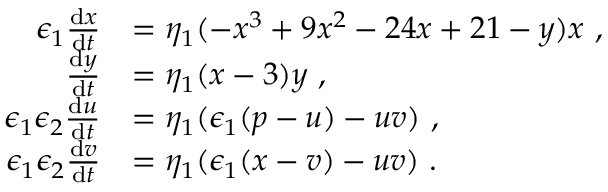Convert formula to latex. <formula><loc_0><loc_0><loc_500><loc_500>\begin{array} { r l } { \epsilon _ { 1 } \frac { d x } { d t } } & { = \eta _ { 1 } ( - x ^ { 3 } + 9 x ^ { 2 } - 2 4 x + 2 1 - y ) x \ , } \\ { \frac { d y } { d t } } & { = \eta _ { 1 } ( x - 3 ) y \ , } \\ { \epsilon _ { 1 } \epsilon _ { 2 } \frac { d u } { d t } } & { = \eta _ { 1 } ( \epsilon _ { 1 } ( p - u ) - u v ) \ , } \\ { \epsilon _ { 1 } \epsilon _ { 2 } \frac { d v } { d t } } & { = \eta _ { 1 } ( \epsilon _ { 1 } ( x - v ) - u v ) \ . } \end{array}</formula> 